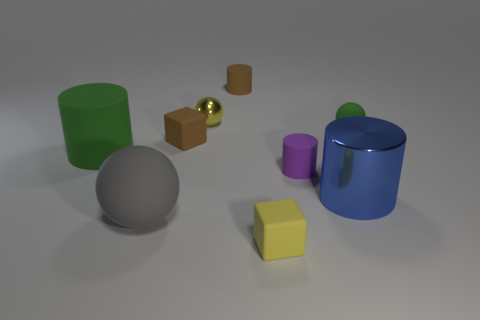What number of rubber things are either tiny yellow balls or big gray spheres?
Your answer should be compact. 1. Do the green matte cylinder and the blue cylinder have the same size?
Make the answer very short. Yes. Is the number of green cylinders that are on the right side of the gray object less than the number of yellow matte blocks behind the large blue cylinder?
Provide a short and direct response. No. Are there any other things that have the same size as the brown rubber cylinder?
Provide a short and direct response. Yes. The brown matte cube has what size?
Ensure brevity in your answer.  Small. What number of big things are yellow cubes or purple rubber cylinders?
Ensure brevity in your answer.  0. Do the gray rubber sphere and the block that is behind the big green cylinder have the same size?
Your answer should be very brief. No. Is there any other thing that has the same shape as the purple thing?
Offer a very short reply. Yes. How many yellow matte cubes are there?
Make the answer very short. 1. How many blue things are large cylinders or small things?
Give a very brief answer. 1. 